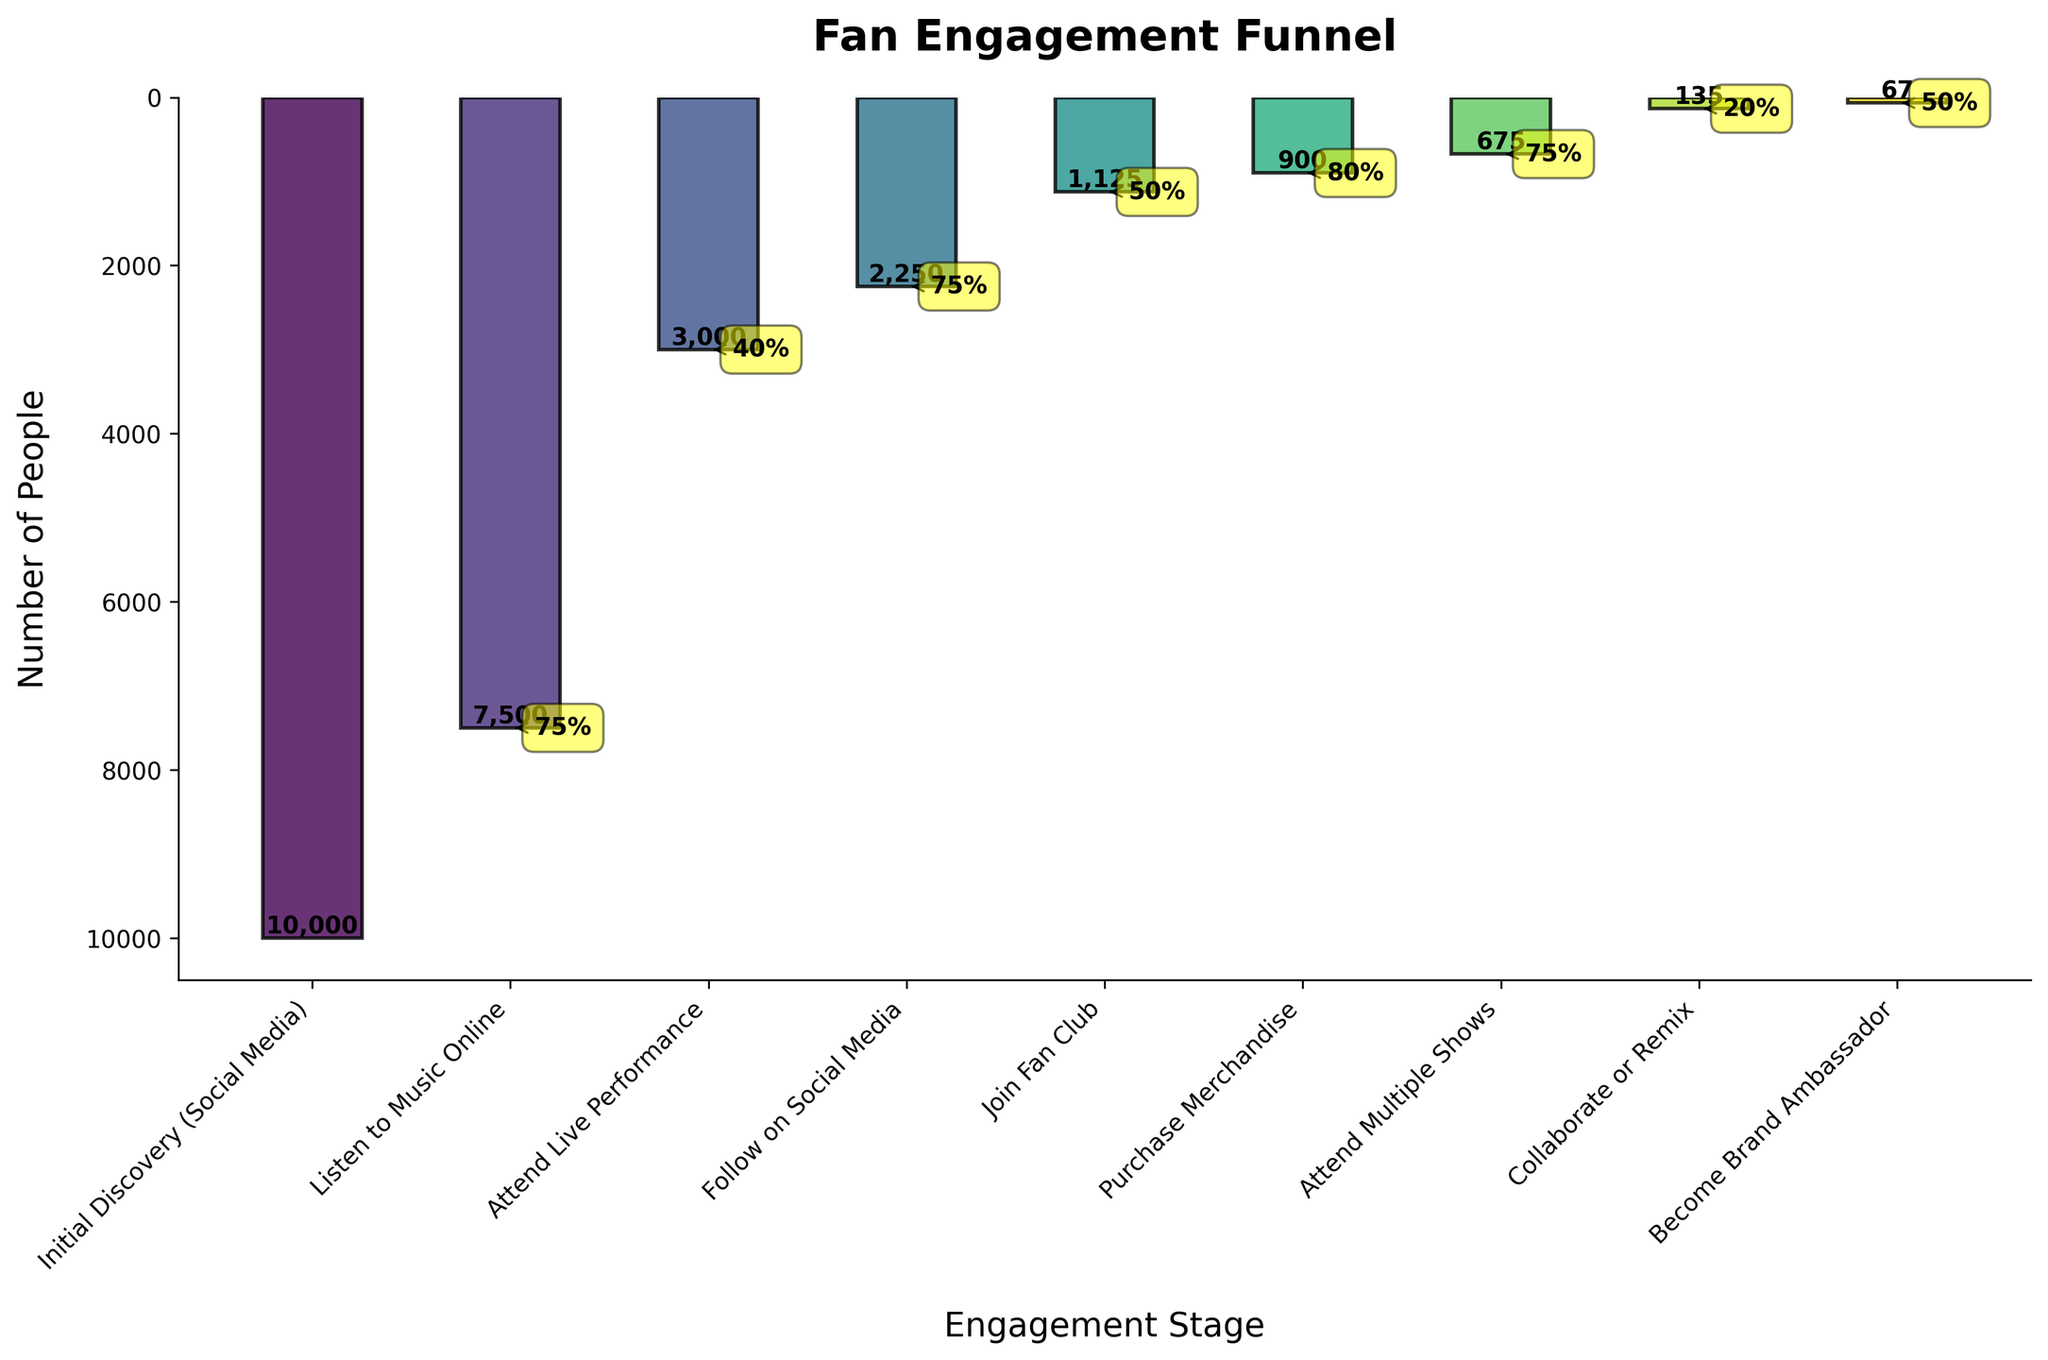What's the title of the chart? The title is written at the top of the chart. It reads "Fan Engagement Funnel".
Answer: Fan Engagement Funnel How many stages of fan engagement are represented in the chart? By counting the bars on the chart, we see there are nine stages represented from 'Initial Discovery (Social Media)' to 'Become Brand Ambassador'.
Answer: Nine What is the conversion rate from 'Attend Live Performance' to 'Follow on Social Media'? Locate the 'Attend Live Performance' bar and the 'Follow on Social Media' bar. The annotation above the 'Follow on Social Media' bar indicates the conversion rate is 75%.
Answer: 75% What stage has the highest number of people in the engagement funnel? By comparing the height of the bars from left to right, the 'Initial Discovery (Social Media)' stage has the highest number of people, 10,000.
Answer: Initial Discovery (Social Media) Which stage has the lowest conversion rate? Check each annotated conversion rate. The lowest conversion rate is 20%, which is the rate for the 'Collaborate or Remix' stage.
Answer: Collaborate or Remix What's the sum of people who attended live performances and those who purchased merchandise? According to the chart, 'Attend Live Performance' has 3,000 people and 'Purchase Merchandise' has 900 people. The sum is calculated as 3,000 + 900 = 3,900.
Answer: 3,900 Which stage has a higher conversion rate: 'Join Fan Club' or 'Become Brand Ambassador'? 'Join Fan Club' has a conversion rate of 50% and 'Become Brand Ambassador' also has a rate of 50%. So, they have equal conversion rates.
Answer: Equal What is the conversion rate from 'Purchase Merchandise' to 'Attend Multiple Shows'? Locate the 'Purchase Merchandise' and 'Attend Multiple Shows' bars, which are annotated with a conversion rate. The rate is 75%.
Answer: 75% How many people became brand ambassadors? Look at the 'Become Brand Ambassador' stage bar; it shows that 67 people became brand ambassadors.
Answer: 67 What is the difference in the number of people between 'Join Fan Club' and 'Follow on Social Media'? Find the 'Join Fan Club' and 'Follow on Social Media' stages. 'Join Fan Club' has 1,125 people, and 'Follow on Social Media' has 2,250 people. The difference is 2,250 - 1,125 = 1,125.
Answer: 1,125 